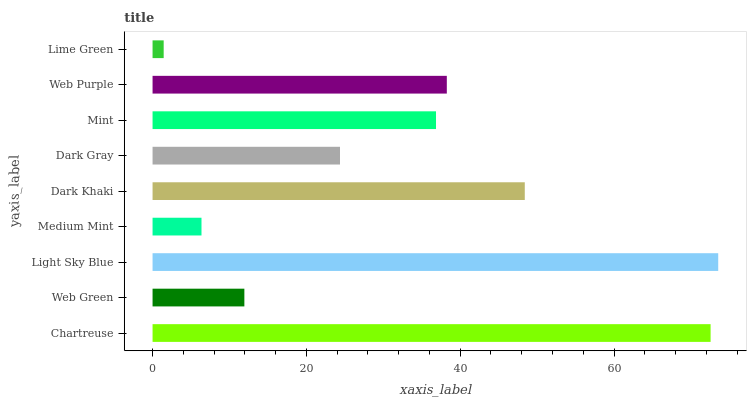Is Lime Green the minimum?
Answer yes or no. Yes. Is Light Sky Blue the maximum?
Answer yes or no. Yes. Is Web Green the minimum?
Answer yes or no. No. Is Web Green the maximum?
Answer yes or no. No. Is Chartreuse greater than Web Green?
Answer yes or no. Yes. Is Web Green less than Chartreuse?
Answer yes or no. Yes. Is Web Green greater than Chartreuse?
Answer yes or no. No. Is Chartreuse less than Web Green?
Answer yes or no. No. Is Mint the high median?
Answer yes or no. Yes. Is Mint the low median?
Answer yes or no. Yes. Is Web Purple the high median?
Answer yes or no. No. Is Chartreuse the low median?
Answer yes or no. No. 